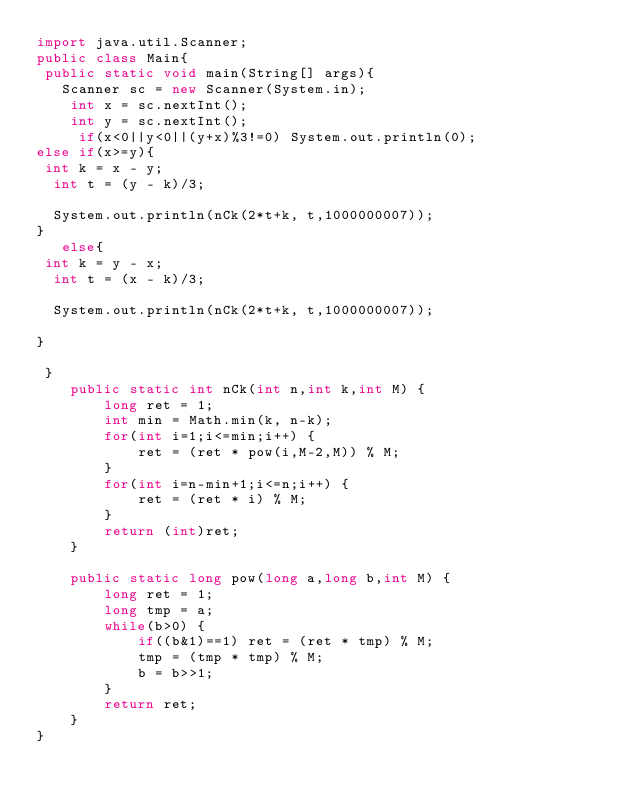Convert code to text. <code><loc_0><loc_0><loc_500><loc_500><_Java_>import java.util.Scanner;
public class Main{
 public static void main(String[] args){
   Scanner sc = new Scanner(System.in);
    int x = sc.nextInt(); 
    int y = sc.nextInt(); 
     if(x<0||y<0||(y+x)%3!=0) System.out.println(0);
else if(x>=y){
 int k = x - y;
  int t = (y - k)/3;
    
  System.out.println(nCk(2*t+k, t,1000000007));
}
   else{
 int k = y - x;
  int t = (x - k)/3;
    
  System.out.println(nCk(2*t+k, t,1000000007));

}

 }
    public static int nCk(int n,int k,int M) {
        long ret = 1;
        int min = Math.min(k, n-k);
        for(int i=1;i<=min;i++) {
            ret = (ret * pow(i,M-2,M)) % M;
        }
        for(int i=n-min+1;i<=n;i++) {
            ret = (ret * i) % M;
        }
        return (int)ret;
    }

    public static long pow(long a,long b,int M) {
        long ret = 1;
        long tmp = a;
        while(b>0) {
            if((b&1)==1) ret = (ret * tmp) % M;
            tmp = (tmp * tmp) % M;
            b = b>>1;
        }
        return ret;
    }
}</code> 